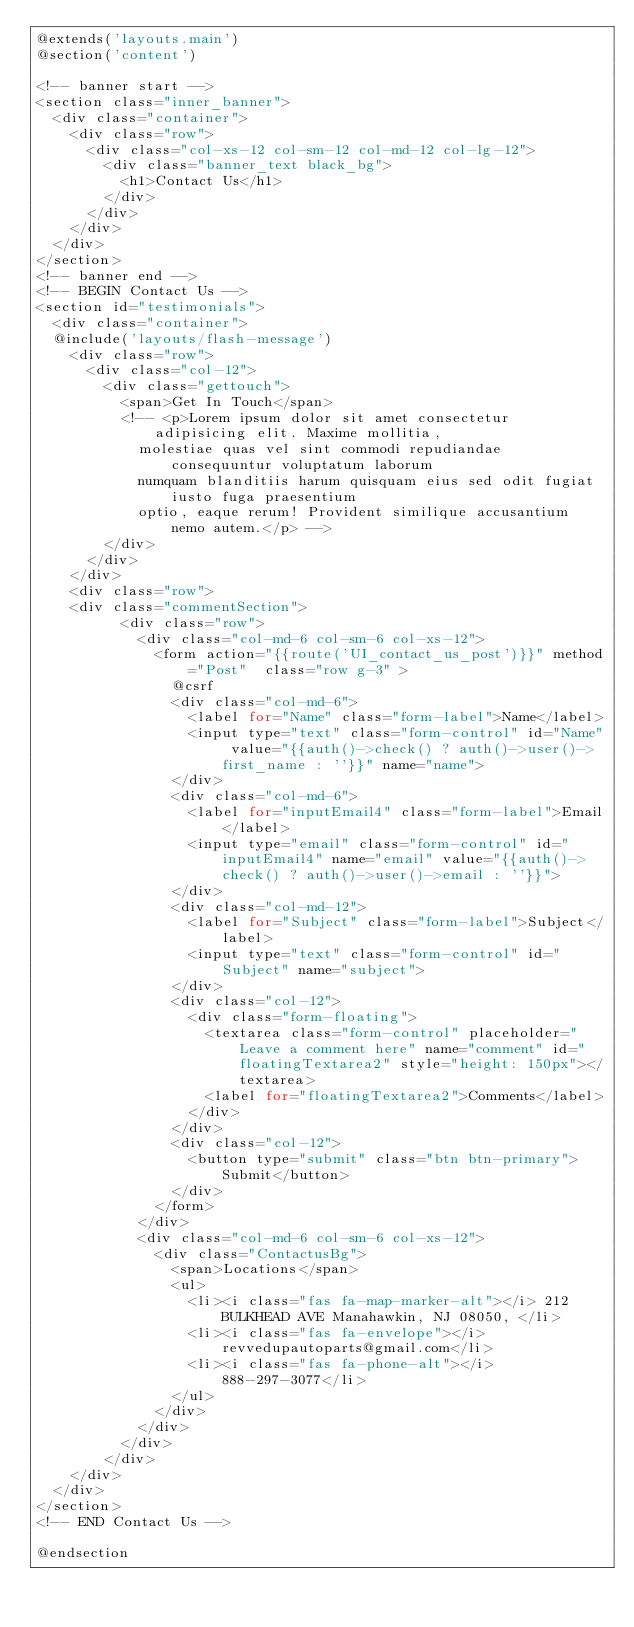Convert code to text. <code><loc_0><loc_0><loc_500><loc_500><_PHP_>@extends('layouts.main')
@section('content')

<!-- banner start -->
<section class="inner_banner">
  <div class="container">
    <div class="row">
      <div class="col-xs-12 col-sm-12 col-md-12 col-lg-12">
        <div class="banner_text black_bg">
          <h1>Contact Us</h1>
        </div>
      </div>
    </div>
  </div>
</section>
<!-- banner end -->
<!-- BEGIN Contact Us -->
<section id="testimonials">
  <div class="container">
  @include('layouts/flash-message')
    <div class="row">
      <div class="col-12">
        <div class="gettouch">
          <span>Get In Touch</span>
          <!-- <p>Lorem ipsum dolor sit amet consectetur adipisicing elit. Maxime mollitia,
            molestiae quas vel sint commodi repudiandae consequuntur voluptatum laborum
            numquam blanditiis harum quisquam eius sed odit fugiat iusto fuga praesentium
            optio, eaque rerum! Provident similique accusantium nemo autem.</p> -->
        </div>
      </div>
    </div>
    <div class="row">
    <div class="commentSection">
          <div class="row">
            <div class="col-md-6 col-sm-6 col-xs-12">
              <form action="{{route('UI_contact_us_post')}}" method="Post"  class="row g-3" >
                @csrf
                <div class="col-md-6">
                  <label for="Name" class="form-label">Name</label>
                  <input type="text" class="form-control" id="Name" value="{{auth()->check() ? auth()->user()->first_name : ''}}" name="name">
                </div>
                <div class="col-md-6">
                  <label for="inputEmail4" class="form-label">Email</label>
                  <input type="email" class="form-control" id="inputEmail4" name="email" value="{{auth()->check() ? auth()->user()->email : ''}}">
                </div>
                <div class="col-md-12">
                  <label for="Subject" class="form-label">Subject</label>
                  <input type="text" class="form-control" id="Subject" name="subject">
                </div>
                <div class="col-12">
                  <div class="form-floating">
                    <textarea class="form-control" placeholder="Leave a comment here" name="comment" id="floatingTextarea2" style="height: 150px"></textarea>
                    <label for="floatingTextarea2">Comments</label>
                  </div>
                </div>
                <div class="col-12">
                  <button type="submit" class="btn btn-primary">Submit</button>
                </div>
              </form>
            </div>
            <div class="col-md-6 col-sm-6 col-xs-12">
              <div class="ContactusBg">
                <span>Locations</span>
                <ul>
                  <li><i class="fas fa-map-marker-alt"></i> 212 BULKHEAD AVE Manahawkin, NJ 08050, </li>
                  <li><i class="fas fa-envelope"></i> revvedupautoparts@gmail.com</li>
                  <li><i class="fas fa-phone-alt"></i> 888-297-3077</li>
                </ul>
              </div>
            </div>
          </div>
        </div>
    </div>
  </div>
</section>
<!-- END Contact Us -->

@endsection</code> 